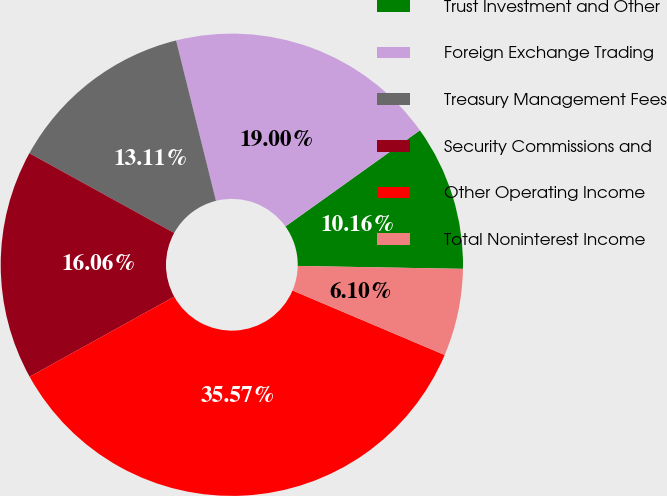Convert chart. <chart><loc_0><loc_0><loc_500><loc_500><pie_chart><fcel>Trust Investment and Other<fcel>Foreign Exchange Trading<fcel>Treasury Management Fees<fcel>Security Commissions and<fcel>Other Operating Income<fcel>Total Noninterest Income<nl><fcel>10.16%<fcel>19.0%<fcel>13.11%<fcel>16.06%<fcel>35.57%<fcel>6.1%<nl></chart> 